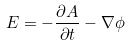Convert formula to latex. <formula><loc_0><loc_0><loc_500><loc_500>E = - { \frac { \partial A } { \partial t } } - \nabla \phi</formula> 